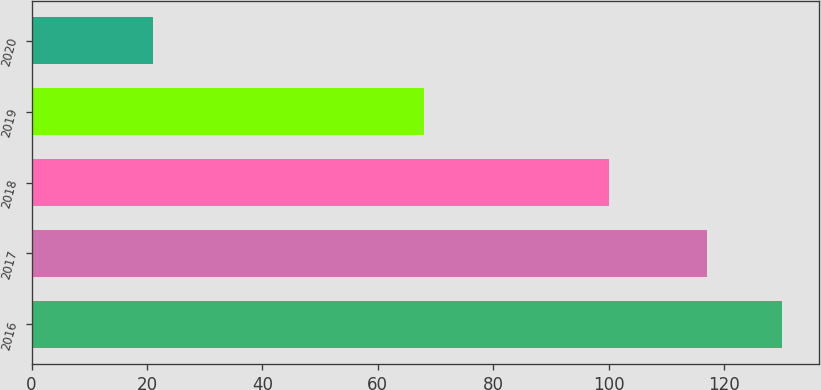Convert chart. <chart><loc_0><loc_0><loc_500><loc_500><bar_chart><fcel>2016<fcel>2017<fcel>2018<fcel>2019<fcel>2020<nl><fcel>130<fcel>117<fcel>100<fcel>68<fcel>21<nl></chart> 